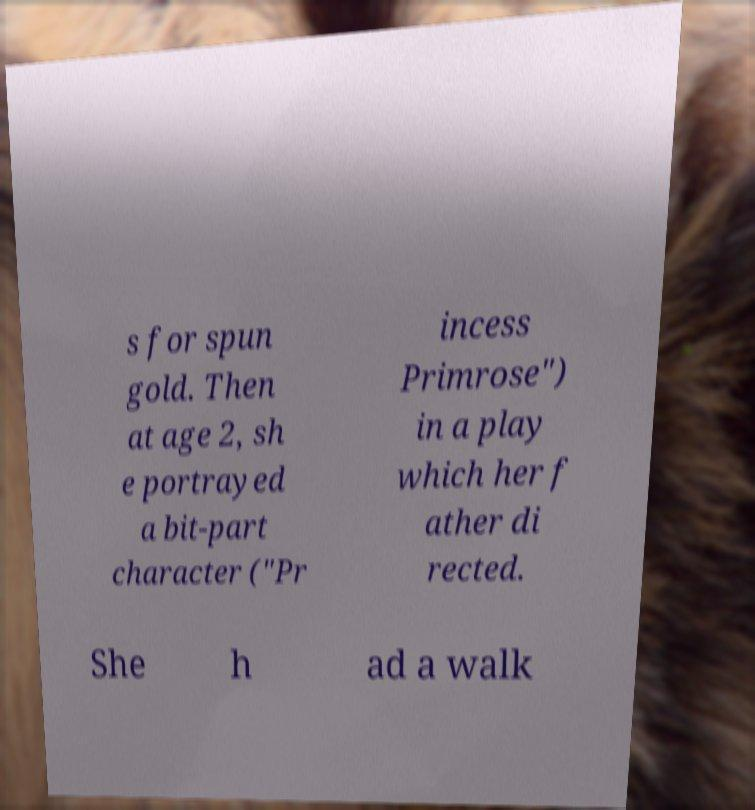There's text embedded in this image that I need extracted. Can you transcribe it verbatim? s for spun gold. Then at age 2, sh e portrayed a bit-part character ("Pr incess Primrose") in a play which her f ather di rected. She h ad a walk 